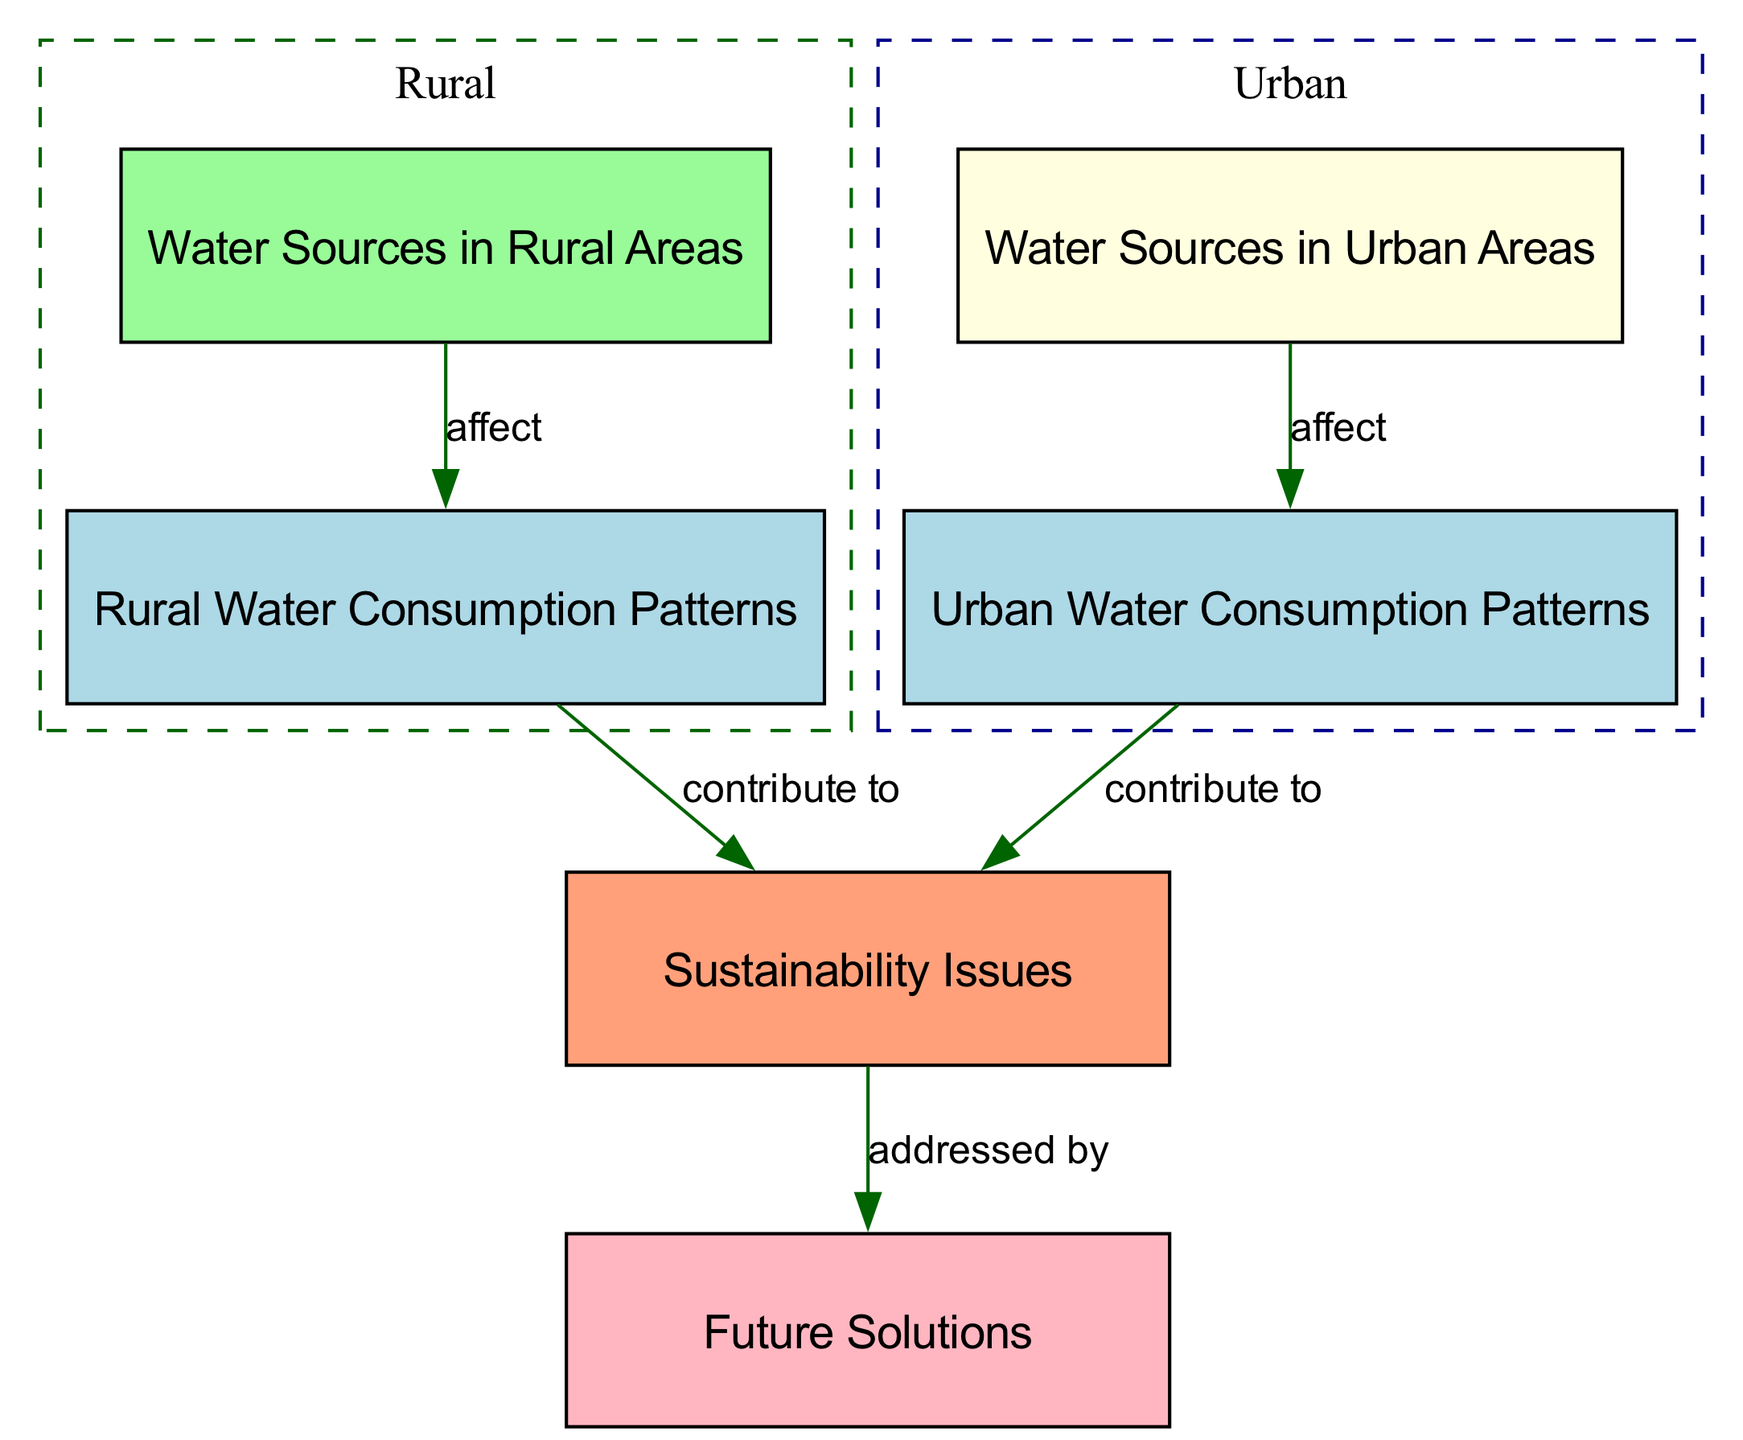What is the color of the water sources in rural areas? The node representing water sources in rural areas is colored pale green. This information can be directly identified in the diagram where the color coding is displayed alongside the node labels.
Answer: pale green How many nodes are there in the diagram? By counting each distinct labeled element connected within the diagram, we find that there are a total of 6 nodes: rural water sources, urban water sources, rural consumption patterns, urban consumption patterns, sustainability issues, and future solutions.
Answer: 6 What relationship exists between urban consumption patterns and sustainability issues? The diagram shows an edge from urban consumption patterns to sustainability issues, labeled "contribute to." This indicates a direct contribution of urban consumption patterns to sustainability challenges.
Answer: contribute to What color represents sustainability issues? The node for sustainability issues is colored lightsalmon, which can be identified when examining the specific color coding for that node within the diagram context.
Answer: lightsalmon What do rural water sources affect? The arrow labeled "affect" from rural water sources points to rural consumption patterns, which indicates that the sources of water in rural areas influence how water is consumed there.
Answer: rural consumption patterns Which two categories are shown as subgraphs in the diagram? The diagram contains two subgraphs: one labeled 'Rural' that includes rural water sources and rural consumption patterns, and another labeled 'Urban' that includes urban water sources and urban consumption patterns. This labeling sets the structure and focus of the diagram into two distinct living environments.
Answer: Rural and Urban What is addressed by future solutions? The edge connecting sustainability issues to future solutions is labeled "addressed by," indicating that future solutions are a response to the challenges posed by sustainability issues identified in both rural and urban water consumption patterns.
Answer: sustainability issues How do urban water sources affect urban consumption patterns? The connection shown in the diagram indicates that urban water sources influence urban consumption patterns, as evidenced by the directed edge labeled "affect" between these two nodes.
Answer: affect What is the primary focus of the diagram? The main focus of the diagram revolves around comparing water consumption patterns and sustainability considerations between rural and urban living spaces, evident through its structured nodes and connections.
Answer: water consumption patterns and sustainability 